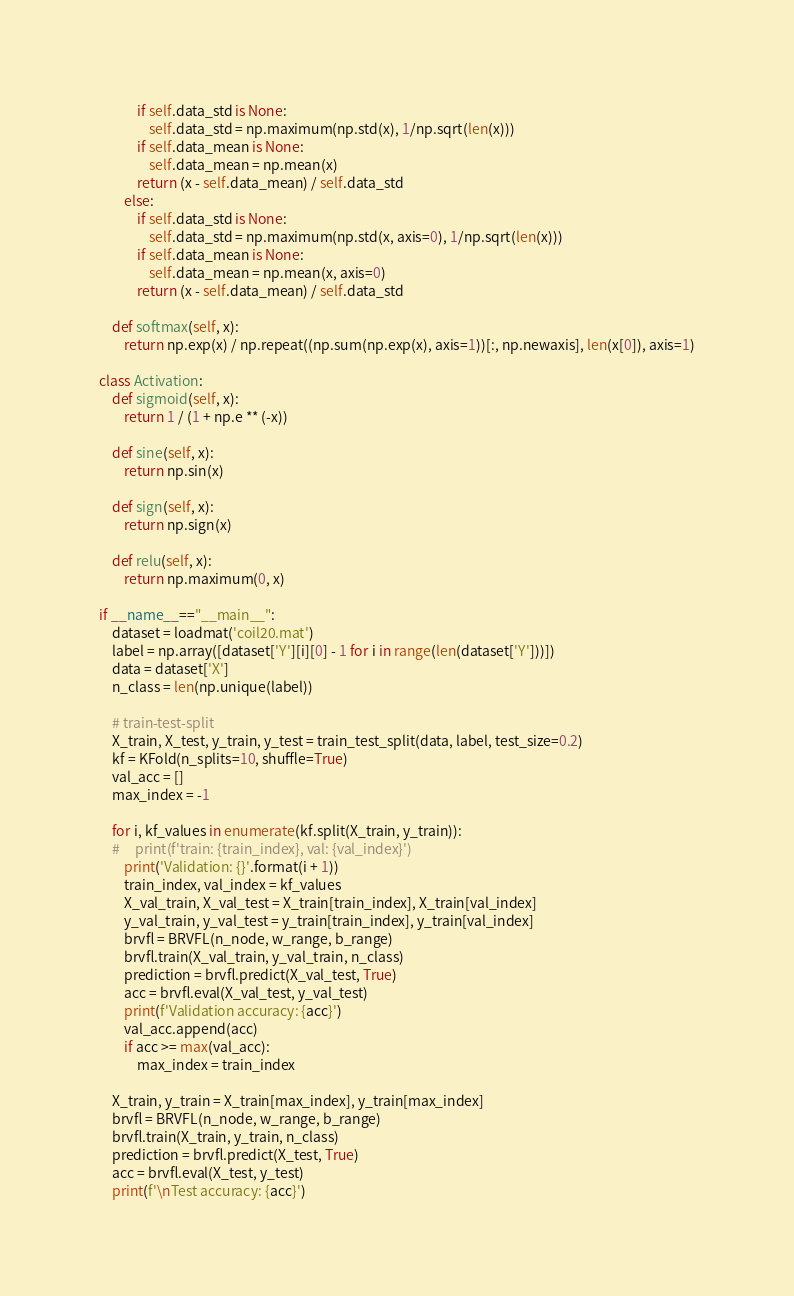Convert code to text. <code><loc_0><loc_0><loc_500><loc_500><_Python_>            if self.data_std is None:
                self.data_std = np.maximum(np.std(x), 1/np.sqrt(len(x)))
            if self.data_mean is None:
                self.data_mean = np.mean(x)
            return (x - self.data_mean) / self.data_std
        else:
            if self.data_std is None:
                self.data_std = np.maximum(np.std(x, axis=0), 1/np.sqrt(len(x)))
            if self.data_mean is None:
                self.data_mean = np.mean(x, axis=0)
            return (x - self.data_mean) / self.data_std

    def softmax(self, x):
        return np.exp(x) / np.repeat((np.sum(np.exp(x), axis=1))[:, np.newaxis], len(x[0]), axis=1)

class Activation:
    def sigmoid(self, x):
        return 1 / (1 + np.e ** (-x))
    
    def sine(self, x):
        return np.sin(x)
    
    def sign(self, x):
        return np.sign(x)
    
    def relu(self, x):
        return np.maximum(0, x)

if __name__=="__main__":
    dataset = loadmat('coil20.mat')
    label = np.array([dataset['Y'][i][0] - 1 for i in range(len(dataset['Y']))])
    data = dataset['X']
    n_class = len(np.unique(label))

    # train-test-split
    X_train, X_test, y_train, y_test = train_test_split(data, label, test_size=0.2)
    kf = KFold(n_splits=10, shuffle=True)
    val_acc = []
    max_index = -1
    
    for i, kf_values in enumerate(kf.split(X_train, y_train)):
    #     print(f'train: {train_index}, val: {val_index}')
        print('Validation: {}'.format(i + 1))
        train_index, val_index = kf_values
        X_val_train, X_val_test = X_train[train_index], X_train[val_index]
        y_val_train, y_val_test = y_train[train_index], y_train[val_index]
        brvfl = BRVFL(n_node, w_range, b_range)
        brvfl.train(X_val_train, y_val_train, n_class)
        prediction = brvfl.predict(X_val_test, True)
        acc = brvfl.eval(X_val_test, y_val_test)
        print(f'Validation accuracy: {acc}')
        val_acc.append(acc)
        if acc >= max(val_acc):
            max_index = train_index

    X_train, y_train = X_train[max_index], y_train[max_index]
    brvfl = BRVFL(n_node, w_range, b_range)
    brvfl.train(X_train, y_train, n_class)
    prediction = brvfl.predict(X_test, True)
    acc = brvfl.eval(X_test, y_test)
    print(f'\nTest accuracy: {acc}')</code> 